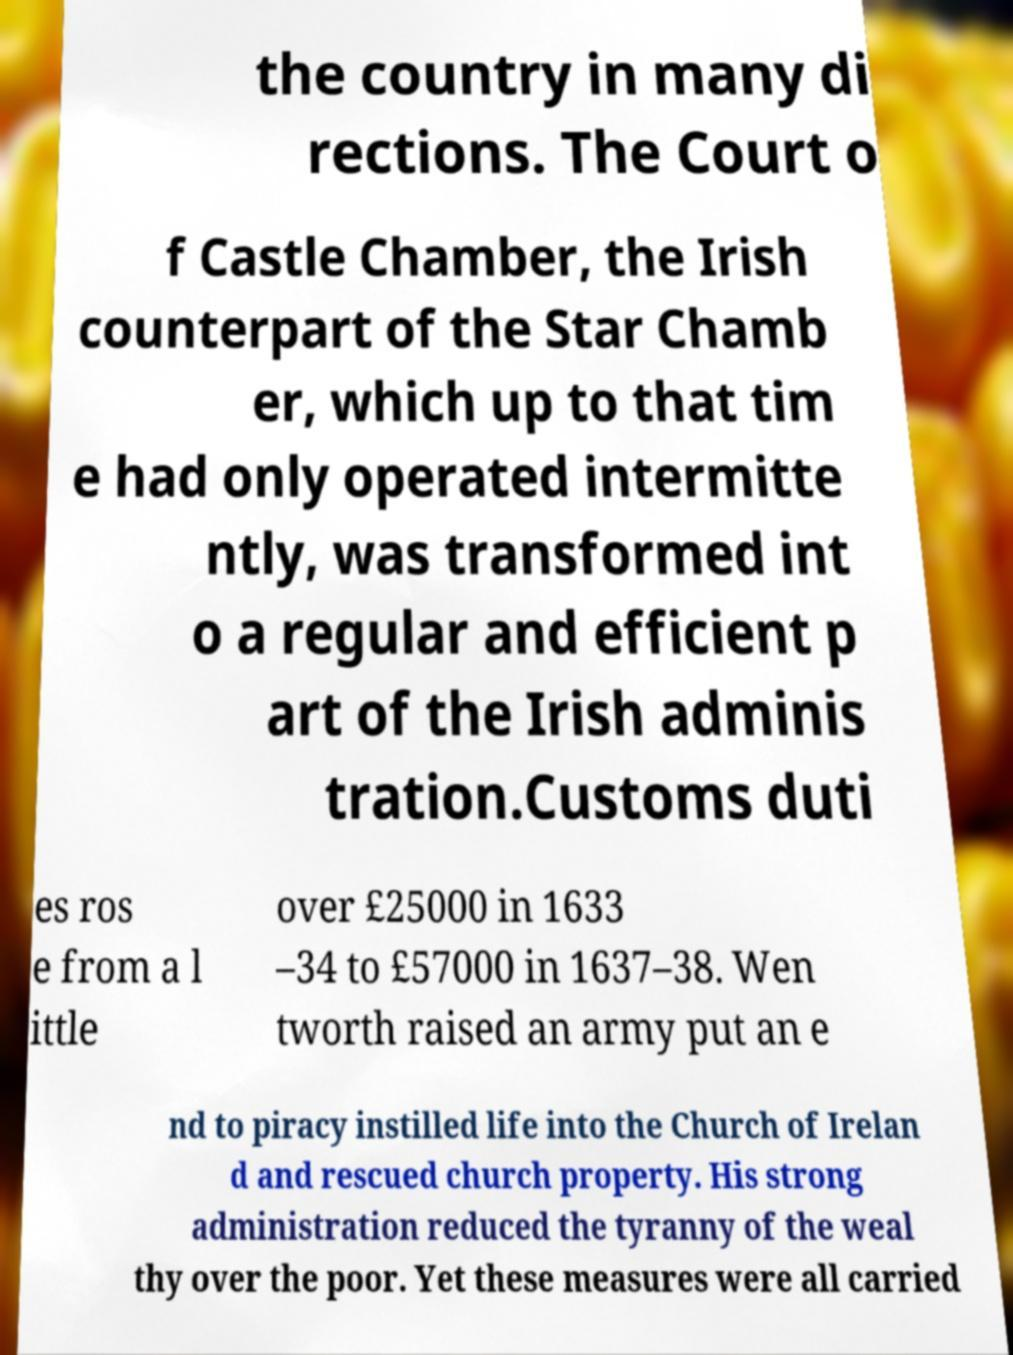Could you assist in decoding the text presented in this image and type it out clearly? the country in many di rections. The Court o f Castle Chamber, the Irish counterpart of the Star Chamb er, which up to that tim e had only operated intermitte ntly, was transformed int o a regular and efficient p art of the Irish adminis tration.Customs duti es ros e from a l ittle over £25000 in 1633 –34 to £57000 in 1637–38. Wen tworth raised an army put an e nd to piracy instilled life into the Church of Irelan d and rescued church property. His strong administration reduced the tyranny of the weal thy over the poor. Yet these measures were all carried 